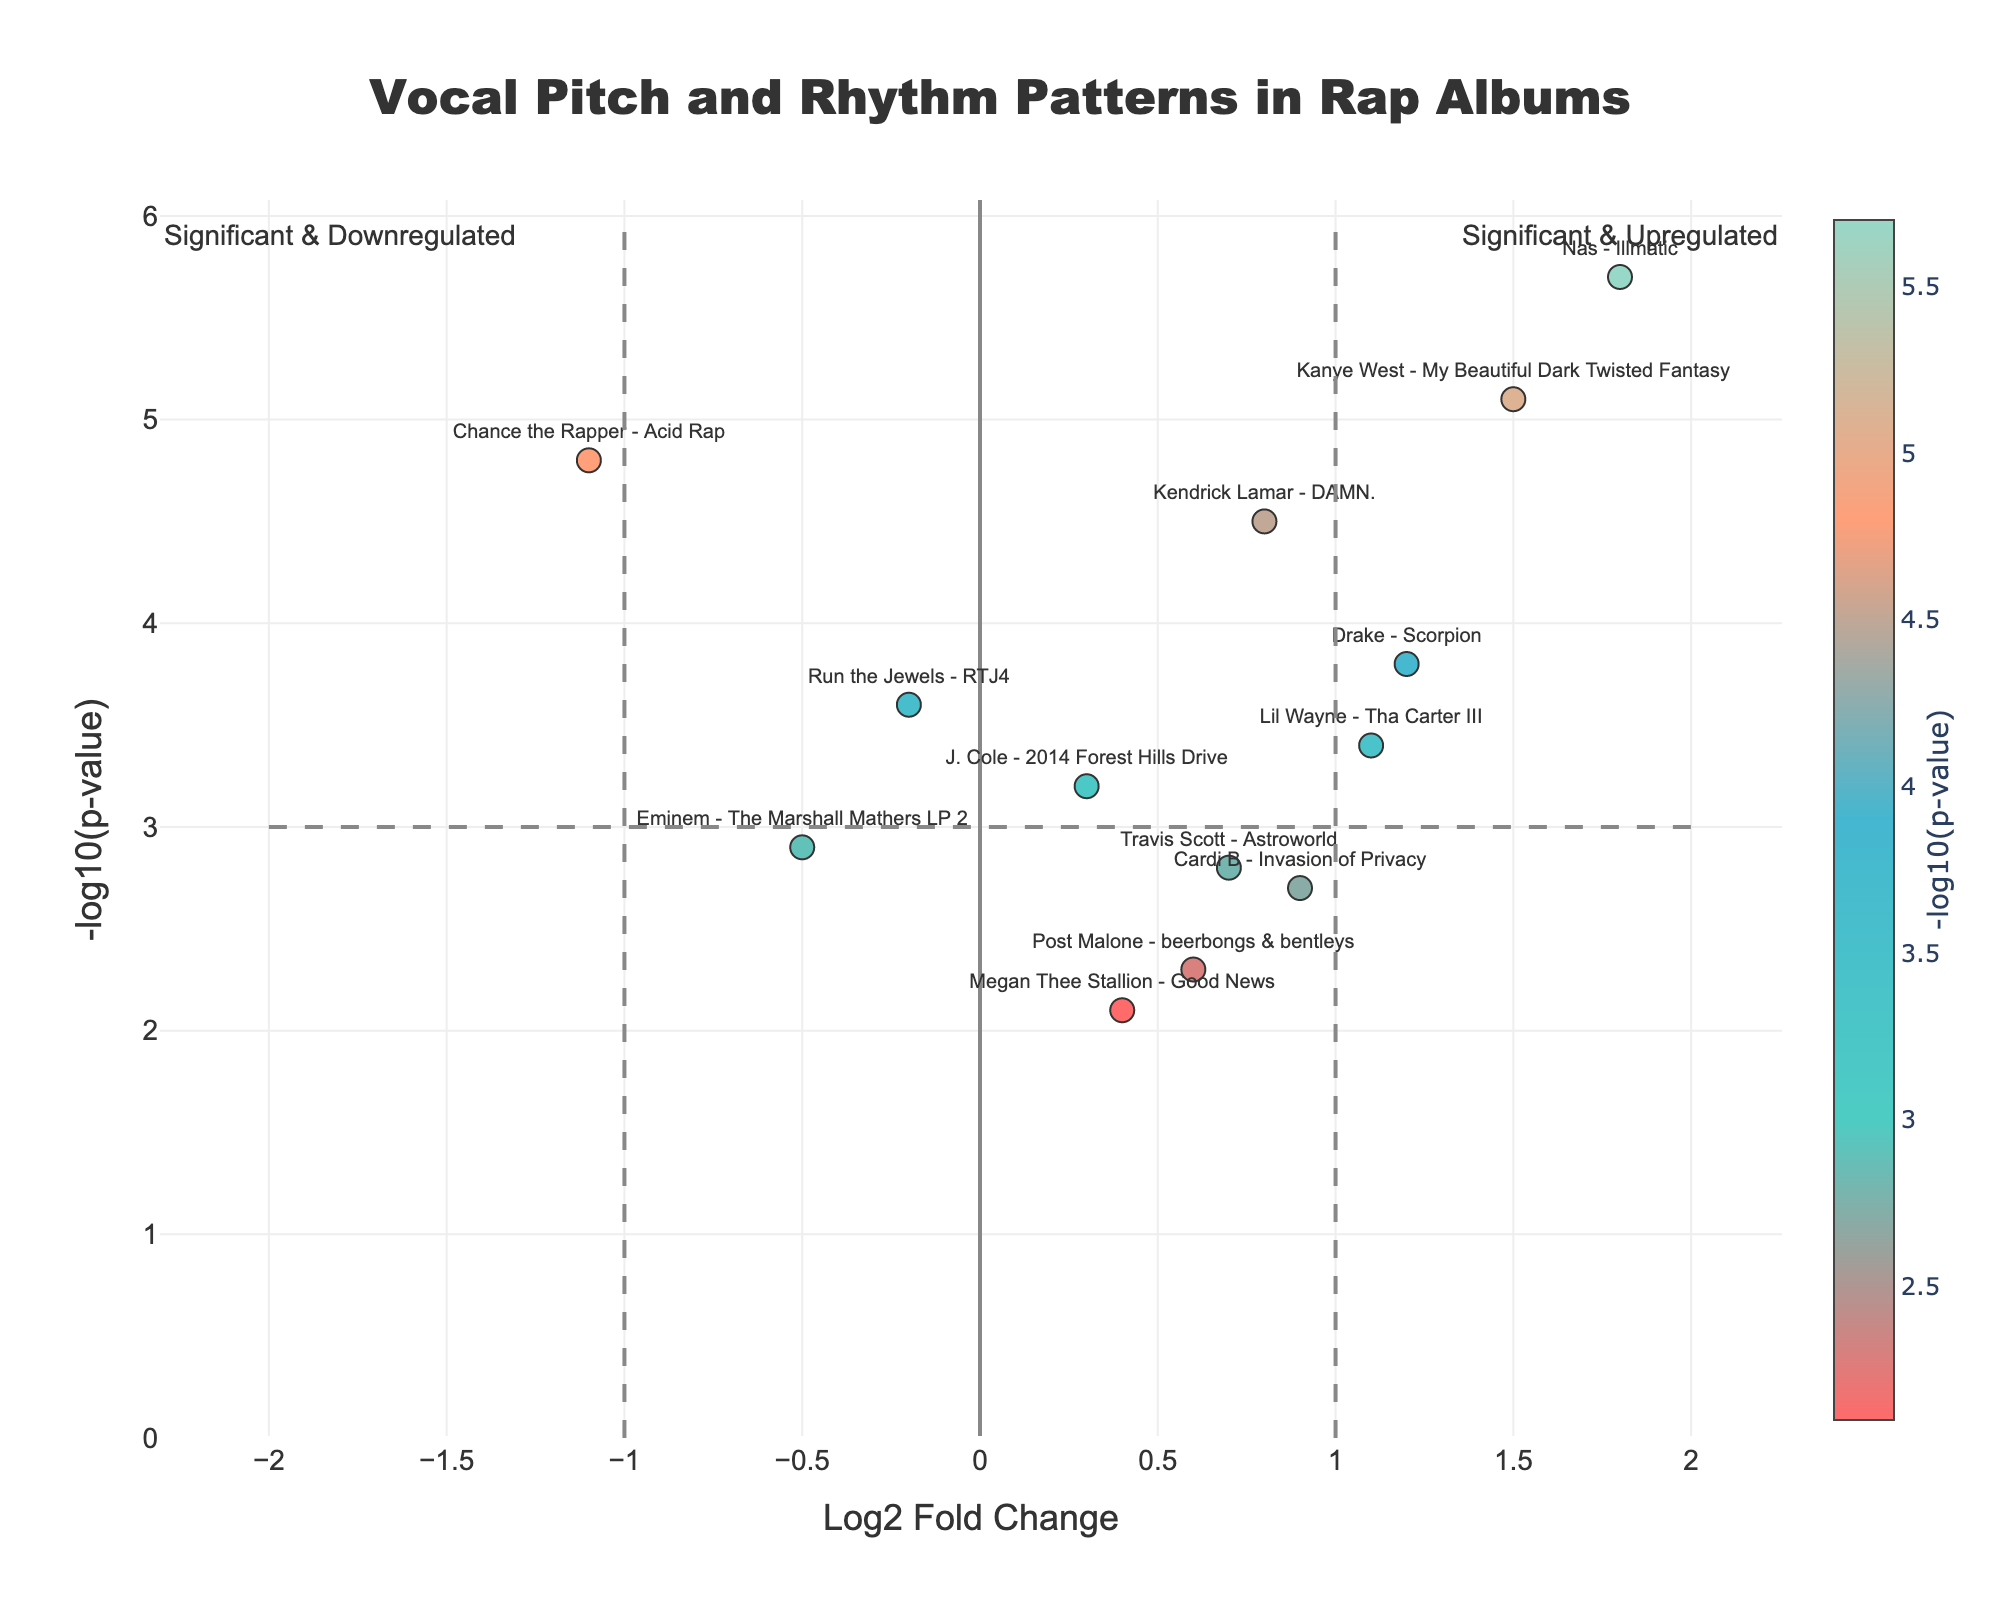What does the title of the figure indicate? The title, "Vocal Pitch and Rhythm Patterns in Rap Albums," suggests the figure compares these patterns across different rap albums.
Answer: The figure compares vocal pitch and rhythm patterns in rap albums Which album has the highest fold change? By examining the x-axis, which represents the Log2 Fold Change, the farthest right data point corresponds to the album "Nas - Illmatic" with a fold change of 1.8.
Answer: Nas - Illmatic How many albums have a Log2 Fold Change greater than 1 and a -log10(p-value) greater than 3? Look at the data points to the right of the vertical line at Log2 Fold Change = 1 and above the horizontal line at -log10(p-value) = 3. There are three such points: "Drake - Scorpion," "Kanye West - My Beautiful Dark Twisted Fantasy," and "Nas - Illmatic."
Answer: Three albums Which rap album is the most statistically significant according to the figure? The y-axis represents the -log10(p-value), with higher values indicating greater significance. The data point with the highest y-value corresponds to "Nas - Illmatic" with a -log10(p-value) of 5.7.
Answer: Nas - Illmatic What patterns are observed in the placement of commercially successful albums versus critically acclaimed ones? Commercially successful albums like "Drake - Scorpion" and "Cardi B - Invasion of Privacy" generally fall around the middle fold change values, while critically acclaimed ones like "Nas - Illmatic" show higher significance with higher fold changes. This suggests that critical acclaim might correlate with more pronounced changes in vocal pitch and rhythm.
Answer: Critical acclaim correlates with higher and significant changes Which album shows a downregulated pattern with significant p-values? Look at the data points to the left of the vertical line at Log2 Fold Change = -1 with a high -log10(p-value). "Chance the Rapper - Acid Rap" fits this criterion with a fold change of -1.1 and -log10(p-value) of 4.8.
Answer: Chance the Rapper - Acid Rap Compare the fold change and significance of "Drake - Scorpion" and "Eminem - The Marshall Mathers LP 2." "Drake - Scorpion" has a fold change of 1.2 and -log10(p-value) of 3.8, while "Eminem - The Marshall Mathers LP 2" has a fold change of -0.5 and -log10(p-value) of 2.9. This indicates that Drake's album has a higher fold change and statistical significance compared to Eminem's.
Answer: Drake - Scorpion has higher fold change and significance Which albums are indicated to have a Log2 Fold Change less than 0 but more than -1? By examining the data points within the specified range on the x-axis, "Eminem - The Marshall Mathers LP 2" (-0.5) and "Run the Jewels - RTJ4" (-0.2) fit this criterion.
Answer: Eminem - The Marshall Mathers LP 2 and Run the Jewels - RTJ4 Which album has a fold change closest to zero but still positive, and what is its p-value? "J. Cole - 2014 Forest Hills Drive" has a Log2 Fold Change of 0.3, which is the closest positive value to zero. Its -log10(p-value) is 3.2.
Answer: J. Cole - 2014 Forest Hills Drive, 3.2 